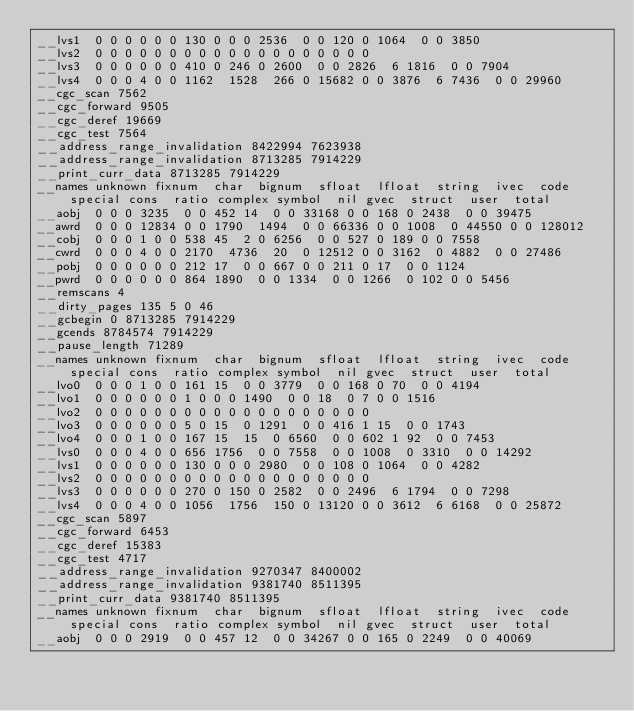<code> <loc_0><loc_0><loc_500><loc_500><_Awk_>__lvs1	0	0	0	0	0	0	130	0	0	0	2536	0	0	120	0	1064	0	0	3850	
__lvs2	0	0	0	0	0	0	0	0	0	0	0	0	0	0	0	0	0	0	0	
__lvs3	0	0	0	0	0	0	410	0	246	0	2600	0	0	2826	6	1816	0	0	7904	
__lvs4	0	0	0	4	0	0	1162	1528	266	0	15682	0	0	3876	6	7436	0	0	29960	
__cgc_scan 7562
__cgc_forward 9505
__cgc_deref 19669
__cgc_test 7564
__address_range_invalidation 8422994 7623938
__address_range_invalidation 8713285 7914229
__print_curr_data 8713285 7914229
__names	unknown	fixnum	char	bignum	sfloat	lfloat	string	ivec	code	special	cons	ratio	complex	symbol	nil	gvec	struct	user	total	
__aobj	0	0	0	3235	0	0	452	14	0	0	33168	0	0	168	0	2438	0	0	39475	
__awrd	0	0	0	12834	0	0	1790	1494	0	0	66336	0	0	1008	0	44550	0	0	128012	
__cobj	0	0	0	1	0	0	538	45	2	0	6256	0	0	527	0	189	0	0	7558	
__cwrd	0	0	0	4	0	0	2170	4736	20	0	12512	0	0	3162	0	4882	0	0	27486	
__pobj	0	0	0	0	0	0	212	17	0	0	667	0	0	211	0	17	0	0	1124	
__pwrd	0	0	0	0	0	0	864	1890	0	0	1334	0	0	1266	0	102	0	0	5456	
__remscans 4
__dirty_pages 135 5 0 46
__gcbegin 0 8713285 7914229
__gcends 8784574 7914229
__pause_length 71289
__names	unknown	fixnum	char	bignum	sfloat	lfloat	string	ivec	code	special	cons	ratio	complex	symbol	nil	gvec	struct	user	total	
__lvo0	0	0	0	1	0	0	161	15	0	0	3779	0	0	168	0	70	0	0	4194	
__lvo1	0	0	0	0	0	0	1	0	0	0	1490	0	0	18	0	7	0	0	1516	
__lvo2	0	0	0	0	0	0	0	0	0	0	0	0	0	0	0	0	0	0	0	
__lvo3	0	0	0	0	0	0	5	0	15	0	1291	0	0	416	1	15	0	0	1743	
__lvo4	0	0	0	1	0	0	167	15	15	0	6560	0	0	602	1	92	0	0	7453	
__lvs0	0	0	0	4	0	0	656	1756	0	0	7558	0	0	1008	0	3310	0	0	14292	
__lvs1	0	0	0	0	0	0	130	0	0	0	2980	0	0	108	0	1064	0	0	4282	
__lvs2	0	0	0	0	0	0	0	0	0	0	0	0	0	0	0	0	0	0	0	
__lvs3	0	0	0	0	0	0	270	0	150	0	2582	0	0	2496	6	1794	0	0	7298	
__lvs4	0	0	0	4	0	0	1056	1756	150	0	13120	0	0	3612	6	6168	0	0	25872	
__cgc_scan 5897
__cgc_forward 6453
__cgc_deref 15383
__cgc_test 4717
__address_range_invalidation 9270347 8400002
__address_range_invalidation 9381740 8511395
__print_curr_data 9381740 8511395
__names	unknown	fixnum	char	bignum	sfloat	lfloat	string	ivec	code	special	cons	ratio	complex	symbol	nil	gvec	struct	user	total	
__aobj	0	0	0	2919	0	0	457	12	0	0	34267	0	0	165	0	2249	0	0	40069	</code> 